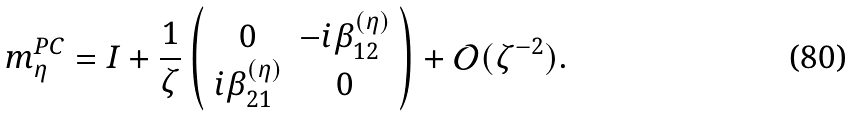Convert formula to latex. <formula><loc_0><loc_0><loc_500><loc_500>m ^ { P C } _ { \eta } = I + \frac { 1 } { \zeta } \left ( \begin{array} { c c } 0 & - i \beta ^ { ( \eta ) } _ { 1 2 } \\ i \beta ^ { ( \eta ) } _ { 2 1 } & 0 \end{array} \right ) + \mathcal { O } ( \zeta ^ { - 2 } ) .</formula> 